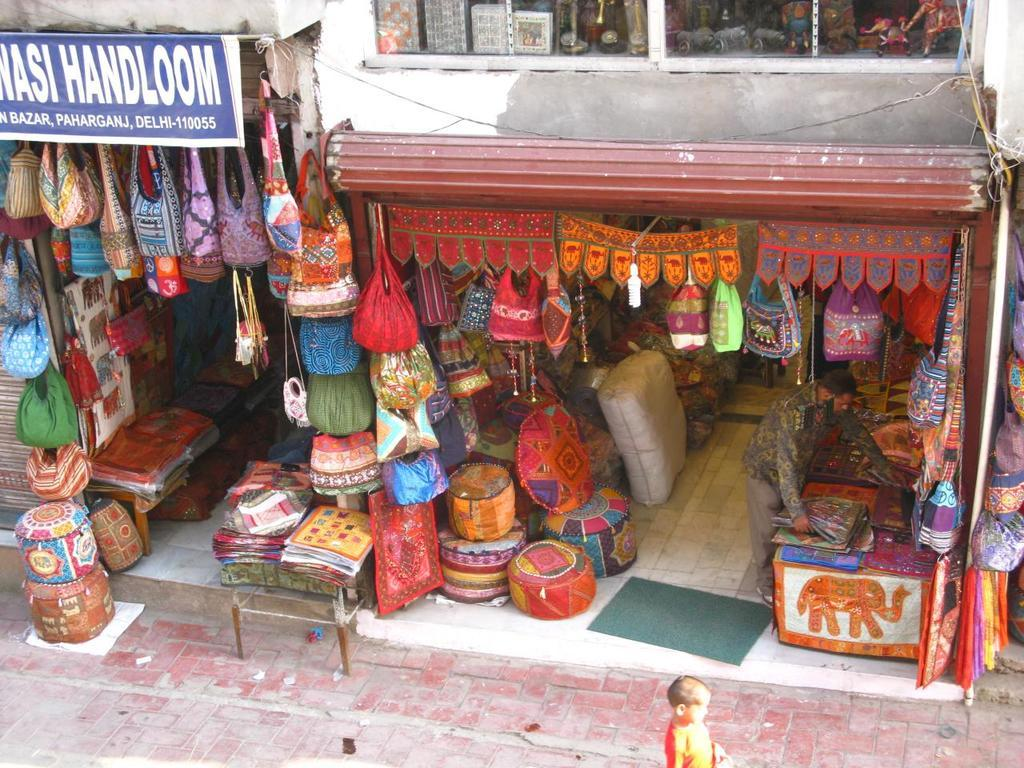<image>
Share a concise interpretation of the image provided. A shop with Handloom on a sign over one part of it. 